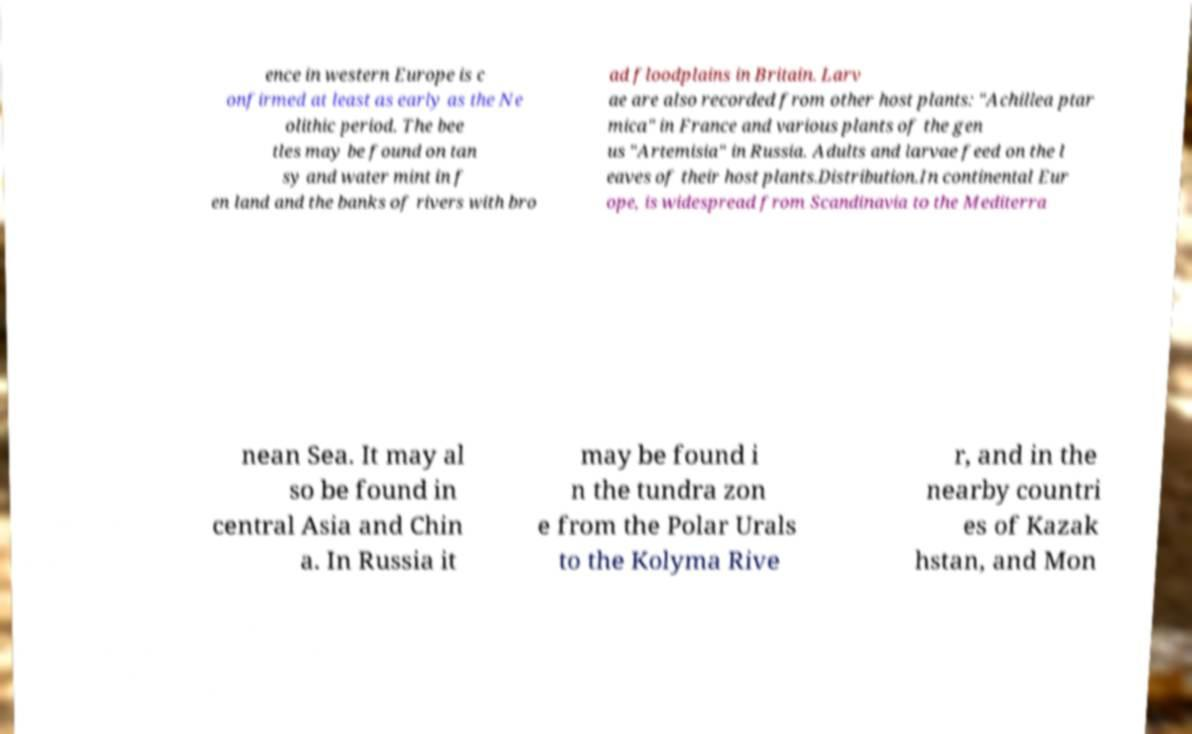I need the written content from this picture converted into text. Can you do that? ence in western Europe is c onfirmed at least as early as the Ne olithic period. The bee tles may be found on tan sy and water mint in f en land and the banks of rivers with bro ad floodplains in Britain. Larv ae are also recorded from other host plants: "Achillea ptar mica" in France and various plants of the gen us "Artemisia" in Russia. Adults and larvae feed on the l eaves of their host plants.Distribution.In continental Eur ope, is widespread from Scandinavia to the Mediterra nean Sea. It may al so be found in central Asia and Chin a. In Russia it may be found i n the tundra zon e from the Polar Urals to the Kolyma Rive r, and in the nearby countri es of Kazak hstan, and Mon 